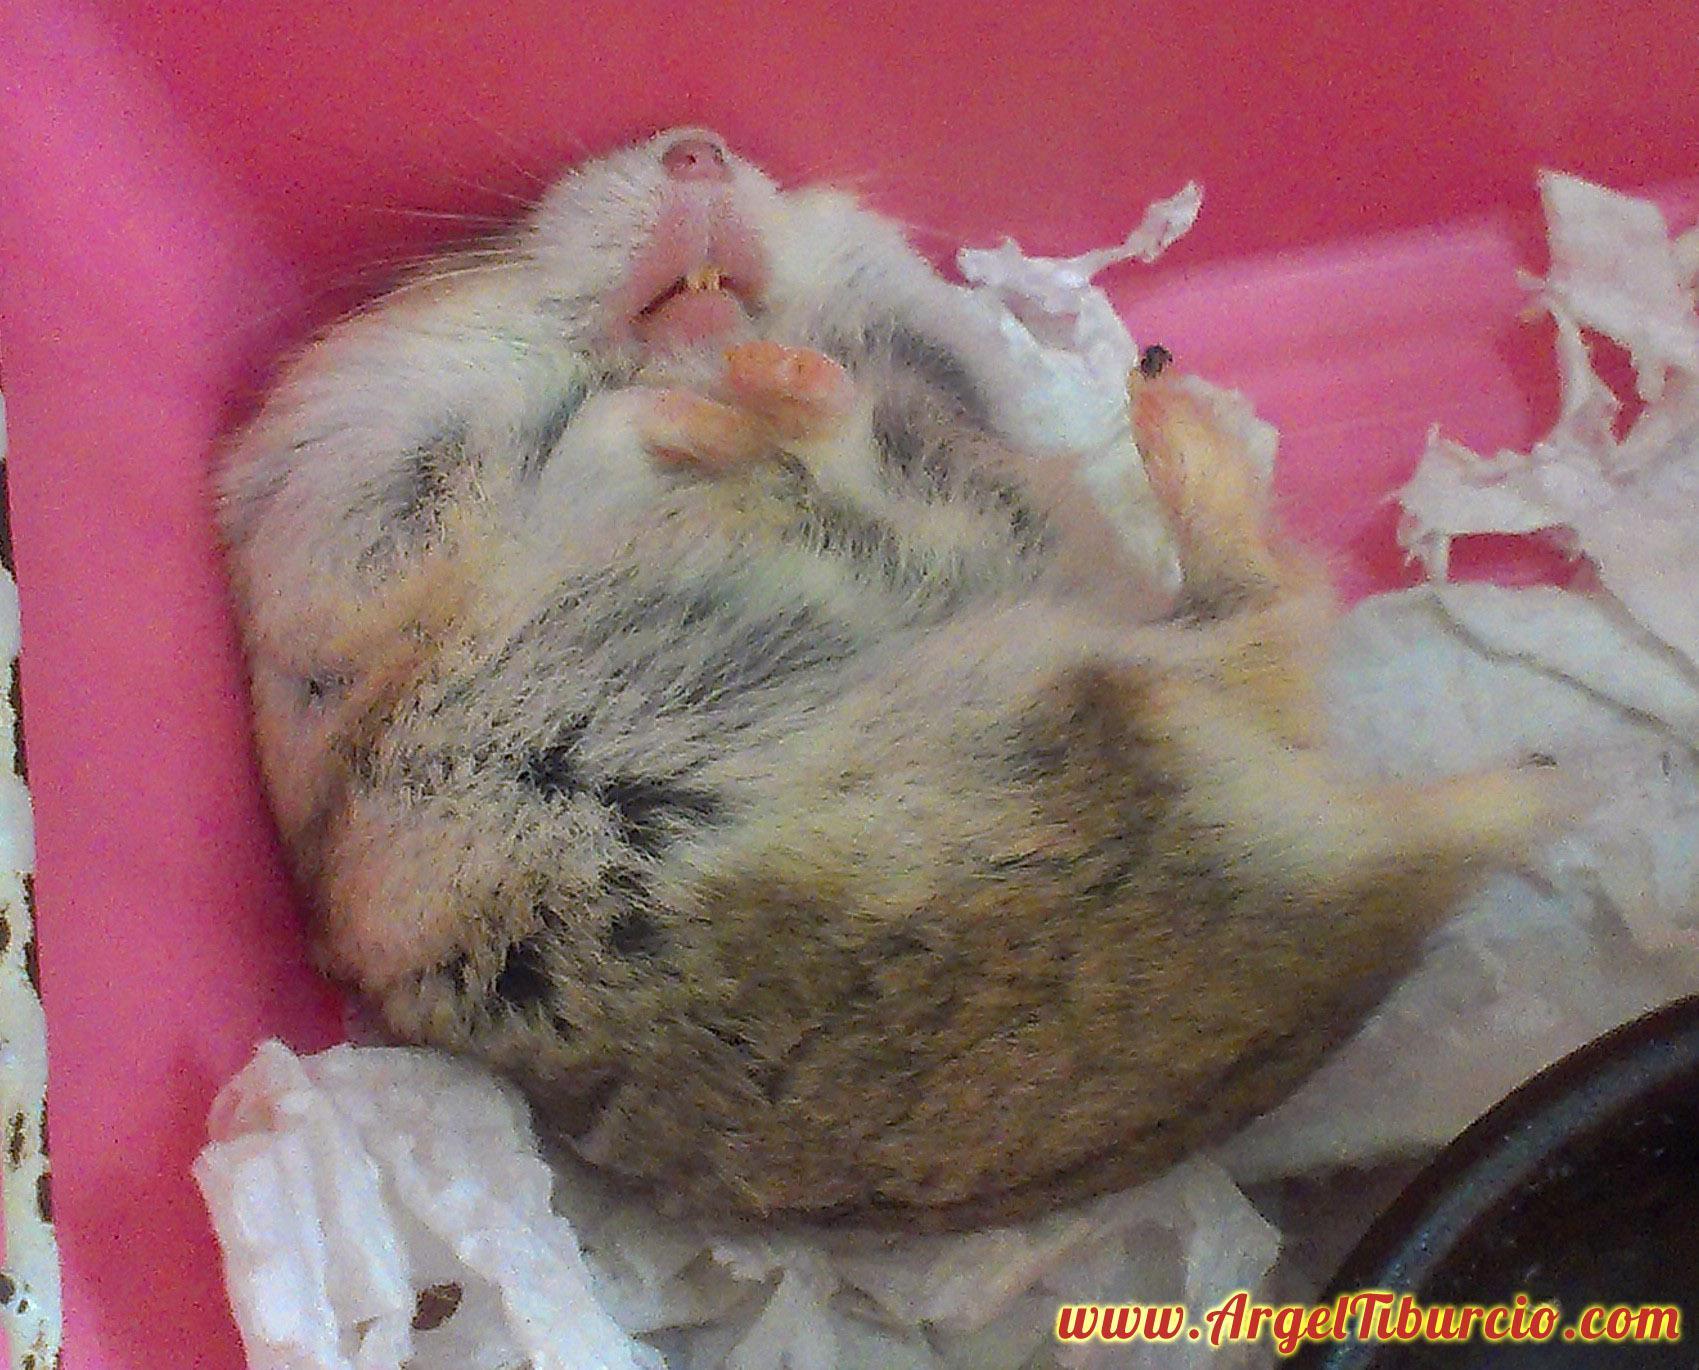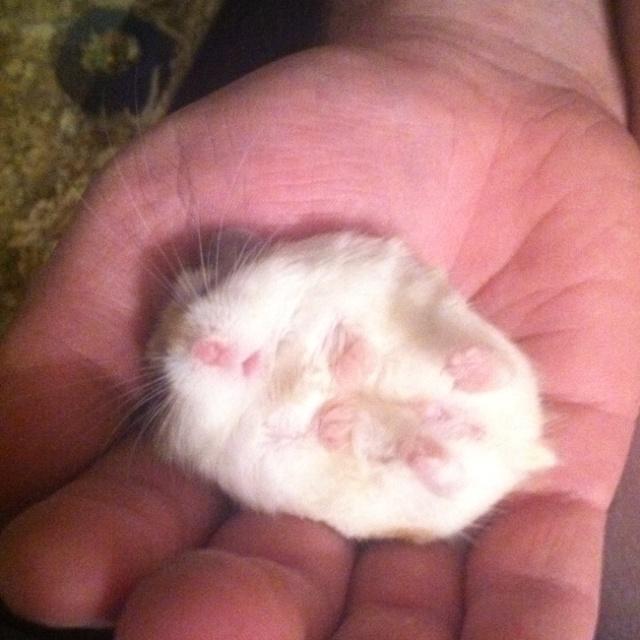The first image is the image on the left, the second image is the image on the right. For the images displayed, is the sentence "An image shows the white-furred belly of a hamster on its back with all four paws in the air." factually correct? Answer yes or no. Yes. The first image is the image on the left, the second image is the image on the right. Assess this claim about the two images: "There is a tiny mammal in a human hand.". Correct or not? Answer yes or no. Yes. 